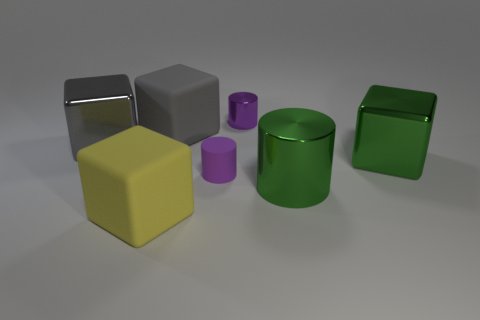Subtract all purple matte cylinders. How many cylinders are left? 2 Add 1 tiny blue metal cylinders. How many objects exist? 8 Subtract all green cubes. How many cubes are left? 3 Subtract all purple cylinders. Subtract all yellow balls. How many cylinders are left? 1 Subtract all green balls. How many red cylinders are left? 0 Subtract all gray matte things. Subtract all purple shiny cylinders. How many objects are left? 5 Add 4 large yellow rubber cubes. How many large yellow rubber cubes are left? 5 Add 3 green blocks. How many green blocks exist? 4 Subtract 0 red spheres. How many objects are left? 7 Subtract all cylinders. How many objects are left? 4 